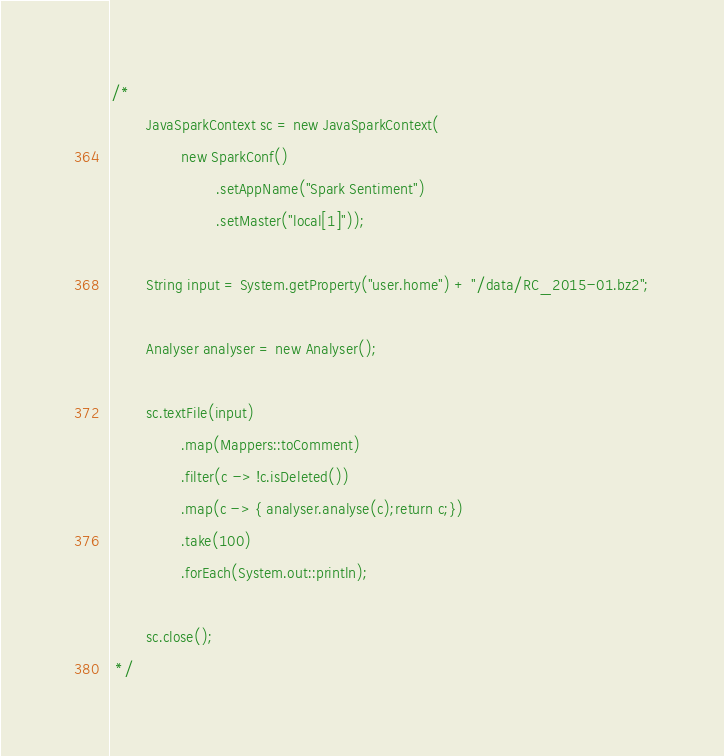<code> <loc_0><loc_0><loc_500><loc_500><_Java_>






/*
        JavaSparkContext sc = new JavaSparkContext(
                new SparkConf()
                        .setAppName("Spark Sentiment")
                        .setMaster("local[1]"));

        String input = System.getProperty("user.home") + "/data/RC_2015-01.bz2";

        Analyser analyser = new Analyser();

        sc.textFile(input)
                .map(Mappers::toComment)
                .filter(c -> !c.isDeleted())
                .map(c -> { analyser.analyse(c);return c;})
                .take(100)
                .forEach(System.out::println);

        sc.close();
 */
</code> 